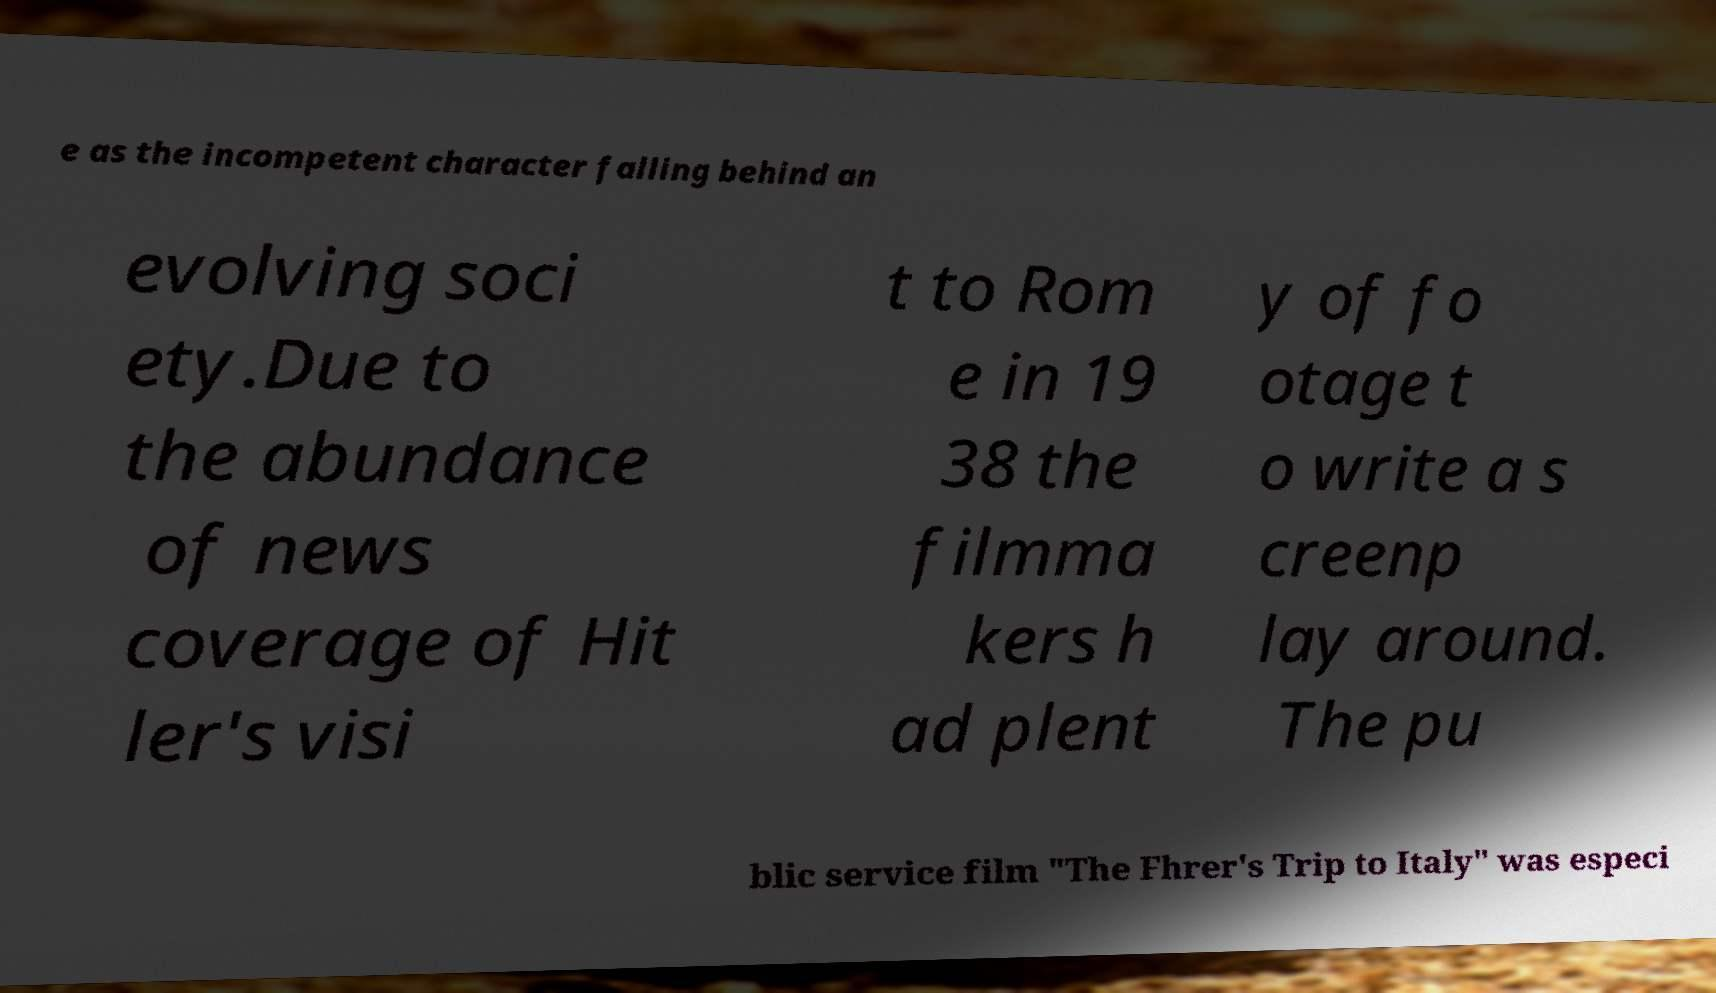Please identify and transcribe the text found in this image. e as the incompetent character falling behind an evolving soci ety.Due to the abundance of news coverage of Hit ler's visi t to Rom e in 19 38 the filmma kers h ad plent y of fo otage t o write a s creenp lay around. The pu blic service film "The Fhrer's Trip to Italy" was especi 